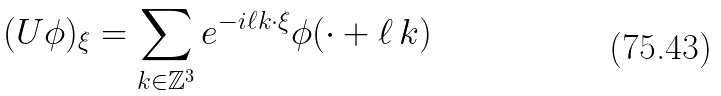Convert formula to latex. <formula><loc_0><loc_0><loc_500><loc_500>( U \phi ) _ { \xi } = \sum _ { k \in \mathbb { Z } ^ { 3 } } e ^ { - i \ell k \cdot \xi } \phi ( \cdot + \ell \, k )</formula> 